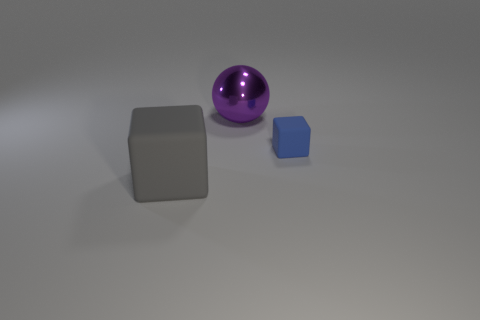Add 2 big red metal things. How many objects exist? 5 Subtract all cubes. How many objects are left? 1 Subtract 0 brown balls. How many objects are left? 3 Subtract all blue rubber blocks. Subtract all big gray things. How many objects are left? 1 Add 3 tiny matte blocks. How many tiny matte blocks are left? 4 Add 3 big yellow metallic cubes. How many big yellow metallic cubes exist? 3 